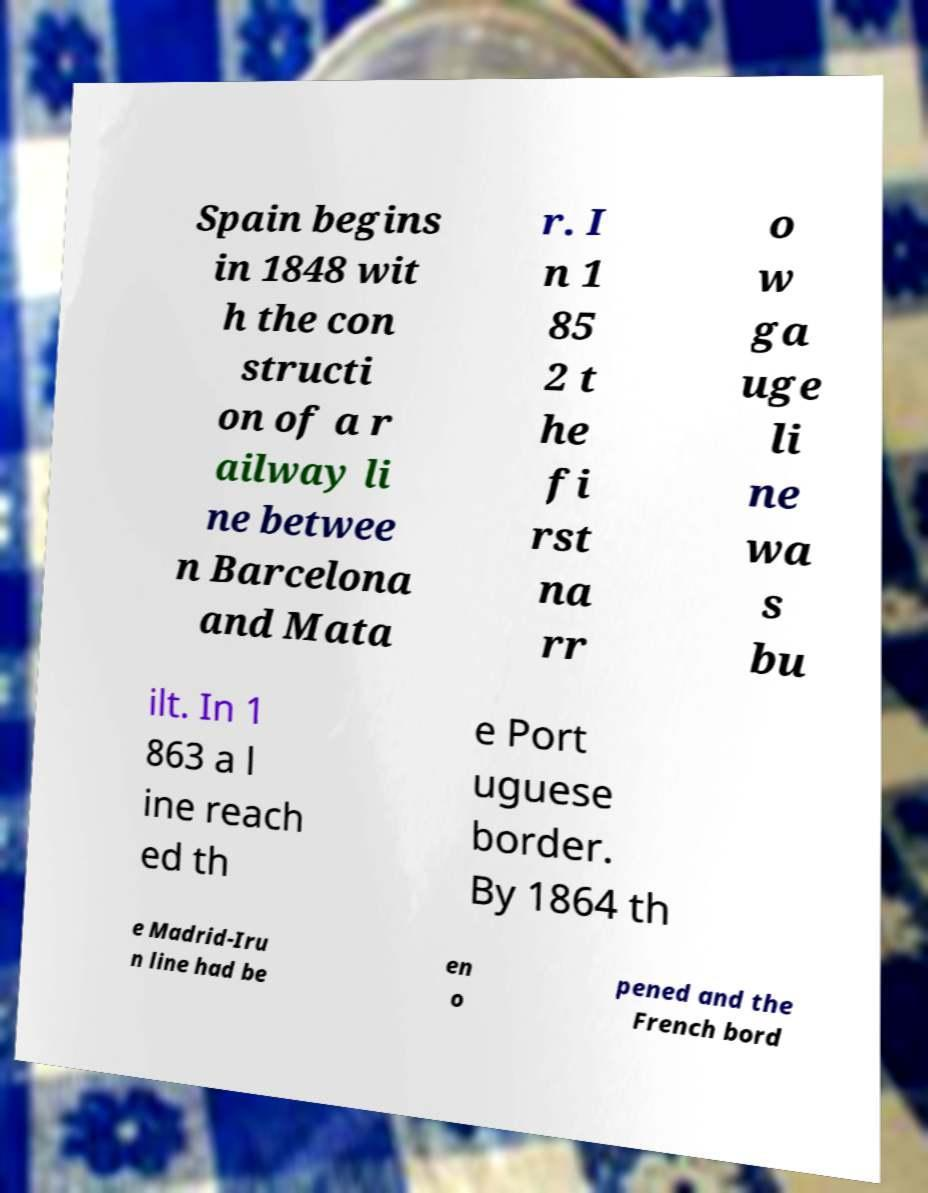Could you assist in decoding the text presented in this image and type it out clearly? Spain begins in 1848 wit h the con structi on of a r ailway li ne betwee n Barcelona and Mata r. I n 1 85 2 t he fi rst na rr o w ga uge li ne wa s bu ilt. In 1 863 a l ine reach ed th e Port uguese border. By 1864 th e Madrid-Iru n line had be en o pened and the French bord 